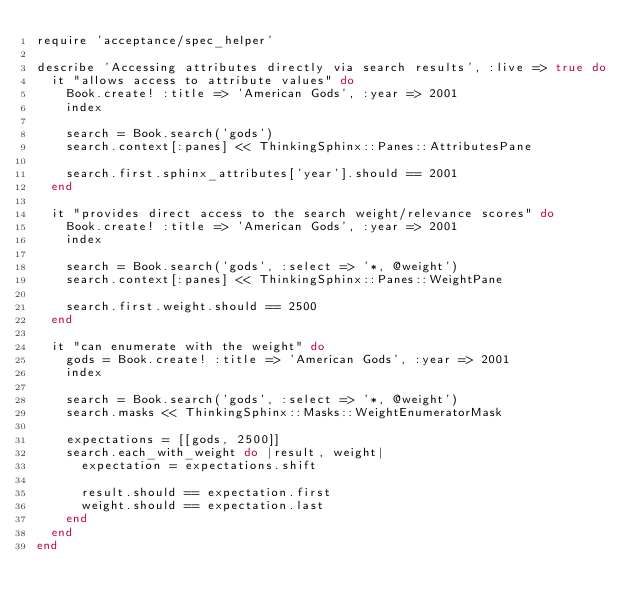<code> <loc_0><loc_0><loc_500><loc_500><_Ruby_>require 'acceptance/spec_helper'

describe 'Accessing attributes directly via search results', :live => true do
  it "allows access to attribute values" do
    Book.create! :title => 'American Gods', :year => 2001
    index

    search = Book.search('gods')
    search.context[:panes] << ThinkingSphinx::Panes::AttributesPane

    search.first.sphinx_attributes['year'].should == 2001
  end

  it "provides direct access to the search weight/relevance scores" do
    Book.create! :title => 'American Gods', :year => 2001
    index

    search = Book.search('gods', :select => '*, @weight')
    search.context[:panes] << ThinkingSphinx::Panes::WeightPane

    search.first.weight.should == 2500
  end

  it "can enumerate with the weight" do
    gods = Book.create! :title => 'American Gods', :year => 2001
    index

    search = Book.search('gods', :select => '*, @weight')
    search.masks << ThinkingSphinx::Masks::WeightEnumeratorMask

    expectations = [[gods, 2500]]
    search.each_with_weight do |result, weight|
      expectation = expectations.shift

      result.should == expectation.first
      weight.should == expectation.last
    end
  end
end
</code> 